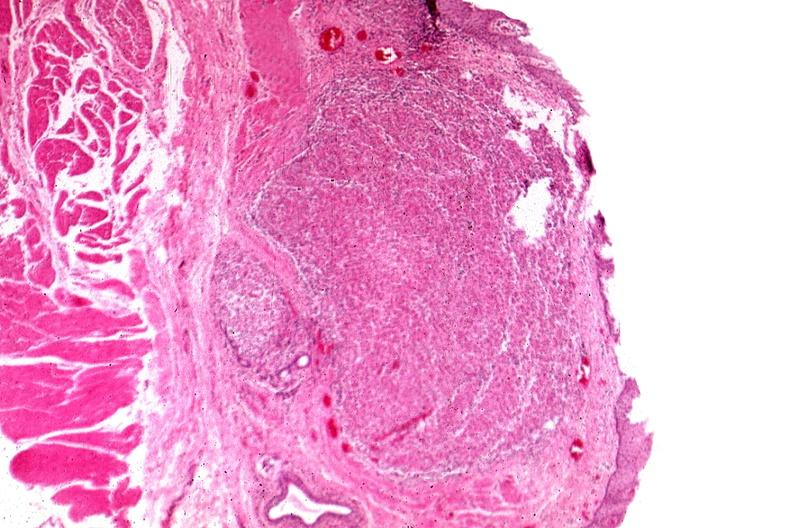s capillary present?
Answer the question using a single word or phrase. No 